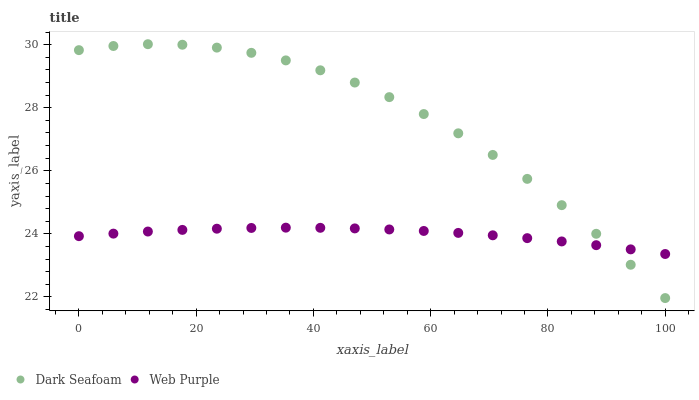Does Web Purple have the minimum area under the curve?
Answer yes or no. Yes. Does Dark Seafoam have the maximum area under the curve?
Answer yes or no. Yes. Does Web Purple have the maximum area under the curve?
Answer yes or no. No. Is Web Purple the smoothest?
Answer yes or no. Yes. Is Dark Seafoam the roughest?
Answer yes or no. Yes. Is Web Purple the roughest?
Answer yes or no. No. Does Dark Seafoam have the lowest value?
Answer yes or no. Yes. Does Web Purple have the lowest value?
Answer yes or no. No. Does Dark Seafoam have the highest value?
Answer yes or no. Yes. Does Web Purple have the highest value?
Answer yes or no. No. Does Dark Seafoam intersect Web Purple?
Answer yes or no. Yes. Is Dark Seafoam less than Web Purple?
Answer yes or no. No. Is Dark Seafoam greater than Web Purple?
Answer yes or no. No. 